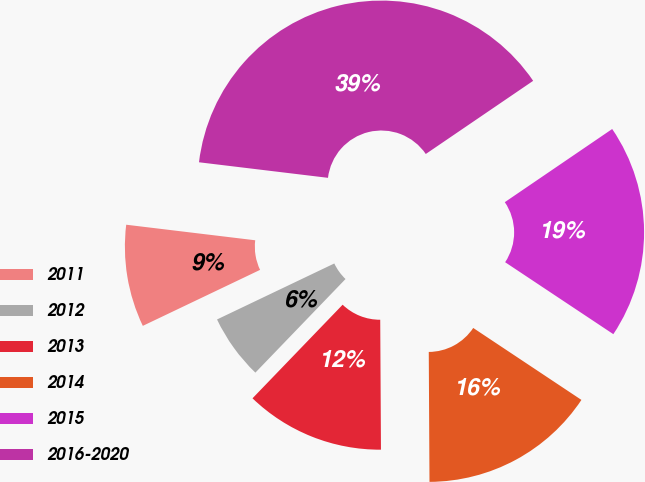Convert chart to OTSL. <chart><loc_0><loc_0><loc_500><loc_500><pie_chart><fcel>2011<fcel>2012<fcel>2013<fcel>2014<fcel>2015<fcel>2016-2020<nl><fcel>9.0%<fcel>5.71%<fcel>12.29%<fcel>15.57%<fcel>18.86%<fcel>38.57%<nl></chart> 